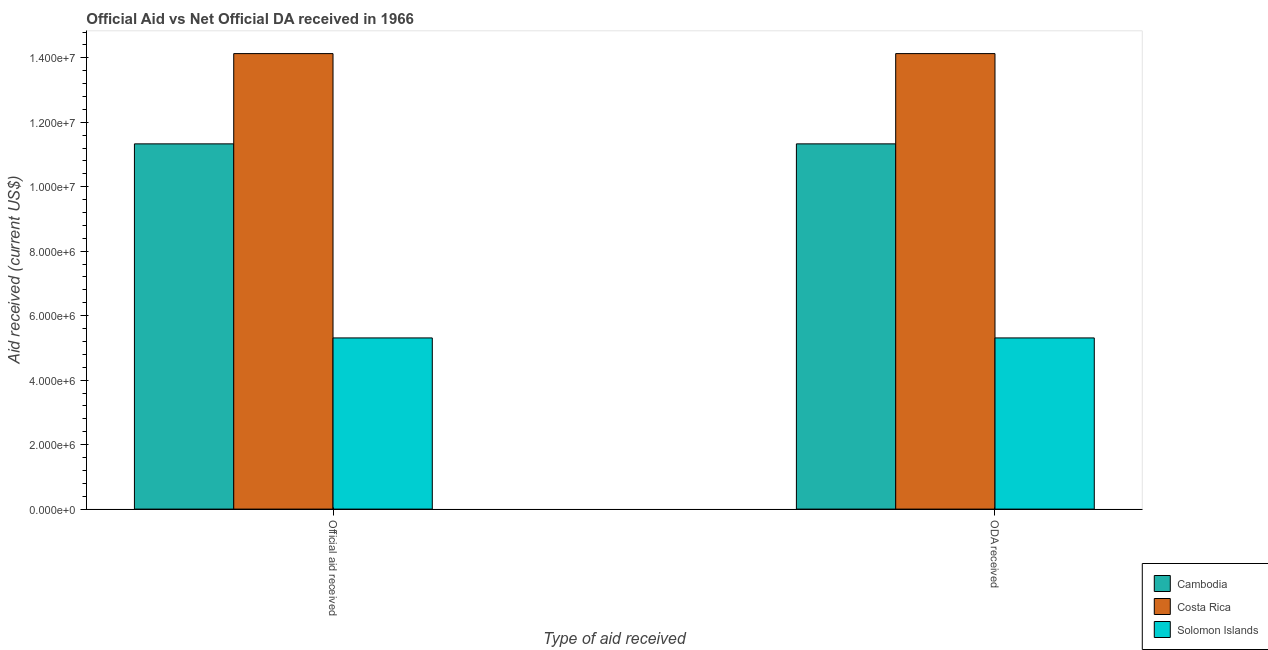Are the number of bars on each tick of the X-axis equal?
Ensure brevity in your answer.  Yes. What is the label of the 1st group of bars from the left?
Keep it short and to the point. Official aid received. What is the oda received in Costa Rica?
Keep it short and to the point. 1.41e+07. Across all countries, what is the maximum official aid received?
Your response must be concise. 1.41e+07. Across all countries, what is the minimum official aid received?
Provide a succinct answer. 5.31e+06. In which country was the oda received minimum?
Your answer should be very brief. Solomon Islands. What is the total official aid received in the graph?
Provide a succinct answer. 3.08e+07. What is the difference between the oda received in Solomon Islands and that in Costa Rica?
Your answer should be compact. -8.82e+06. What is the difference between the oda received in Cambodia and the official aid received in Solomon Islands?
Offer a very short reply. 6.02e+06. What is the average official aid received per country?
Your answer should be very brief. 1.03e+07. What is the difference between the official aid received and oda received in Costa Rica?
Provide a short and direct response. 0. In how many countries, is the oda received greater than 11200000 US$?
Offer a terse response. 2. What is the ratio of the oda received in Costa Rica to that in Solomon Islands?
Offer a terse response. 2.66. What does the 3rd bar from the left in ODA received represents?
Your response must be concise. Solomon Islands. What does the 1st bar from the right in ODA received represents?
Make the answer very short. Solomon Islands. How many bars are there?
Provide a short and direct response. 6. Are the values on the major ticks of Y-axis written in scientific E-notation?
Your response must be concise. Yes. What is the title of the graph?
Provide a succinct answer. Official Aid vs Net Official DA received in 1966 . What is the label or title of the X-axis?
Offer a very short reply. Type of aid received. What is the label or title of the Y-axis?
Your answer should be compact. Aid received (current US$). What is the Aid received (current US$) in Cambodia in Official aid received?
Your response must be concise. 1.13e+07. What is the Aid received (current US$) in Costa Rica in Official aid received?
Provide a short and direct response. 1.41e+07. What is the Aid received (current US$) in Solomon Islands in Official aid received?
Your answer should be very brief. 5.31e+06. What is the Aid received (current US$) of Cambodia in ODA received?
Give a very brief answer. 1.13e+07. What is the Aid received (current US$) in Costa Rica in ODA received?
Give a very brief answer. 1.41e+07. What is the Aid received (current US$) of Solomon Islands in ODA received?
Make the answer very short. 5.31e+06. Across all Type of aid received, what is the maximum Aid received (current US$) in Cambodia?
Offer a very short reply. 1.13e+07. Across all Type of aid received, what is the maximum Aid received (current US$) in Costa Rica?
Give a very brief answer. 1.41e+07. Across all Type of aid received, what is the maximum Aid received (current US$) of Solomon Islands?
Provide a short and direct response. 5.31e+06. Across all Type of aid received, what is the minimum Aid received (current US$) of Cambodia?
Your response must be concise. 1.13e+07. Across all Type of aid received, what is the minimum Aid received (current US$) of Costa Rica?
Your answer should be compact. 1.41e+07. Across all Type of aid received, what is the minimum Aid received (current US$) in Solomon Islands?
Your response must be concise. 5.31e+06. What is the total Aid received (current US$) in Cambodia in the graph?
Give a very brief answer. 2.27e+07. What is the total Aid received (current US$) of Costa Rica in the graph?
Give a very brief answer. 2.83e+07. What is the total Aid received (current US$) of Solomon Islands in the graph?
Give a very brief answer. 1.06e+07. What is the difference between the Aid received (current US$) in Costa Rica in Official aid received and that in ODA received?
Provide a succinct answer. 0. What is the difference between the Aid received (current US$) in Cambodia in Official aid received and the Aid received (current US$) in Costa Rica in ODA received?
Offer a terse response. -2.80e+06. What is the difference between the Aid received (current US$) in Cambodia in Official aid received and the Aid received (current US$) in Solomon Islands in ODA received?
Your response must be concise. 6.02e+06. What is the difference between the Aid received (current US$) in Costa Rica in Official aid received and the Aid received (current US$) in Solomon Islands in ODA received?
Provide a short and direct response. 8.82e+06. What is the average Aid received (current US$) of Cambodia per Type of aid received?
Offer a very short reply. 1.13e+07. What is the average Aid received (current US$) of Costa Rica per Type of aid received?
Give a very brief answer. 1.41e+07. What is the average Aid received (current US$) in Solomon Islands per Type of aid received?
Give a very brief answer. 5.31e+06. What is the difference between the Aid received (current US$) of Cambodia and Aid received (current US$) of Costa Rica in Official aid received?
Your answer should be compact. -2.80e+06. What is the difference between the Aid received (current US$) of Cambodia and Aid received (current US$) of Solomon Islands in Official aid received?
Offer a terse response. 6.02e+06. What is the difference between the Aid received (current US$) in Costa Rica and Aid received (current US$) in Solomon Islands in Official aid received?
Offer a terse response. 8.82e+06. What is the difference between the Aid received (current US$) of Cambodia and Aid received (current US$) of Costa Rica in ODA received?
Your response must be concise. -2.80e+06. What is the difference between the Aid received (current US$) of Cambodia and Aid received (current US$) of Solomon Islands in ODA received?
Provide a succinct answer. 6.02e+06. What is the difference between the Aid received (current US$) in Costa Rica and Aid received (current US$) in Solomon Islands in ODA received?
Keep it short and to the point. 8.82e+06. What is the ratio of the Aid received (current US$) of Cambodia in Official aid received to that in ODA received?
Offer a terse response. 1. What is the ratio of the Aid received (current US$) of Costa Rica in Official aid received to that in ODA received?
Your answer should be compact. 1. What is the difference between the highest and the second highest Aid received (current US$) in Cambodia?
Your answer should be compact. 0. What is the difference between the highest and the second highest Aid received (current US$) of Costa Rica?
Keep it short and to the point. 0. What is the difference between the highest and the second highest Aid received (current US$) in Solomon Islands?
Offer a very short reply. 0. What is the difference between the highest and the lowest Aid received (current US$) in Cambodia?
Ensure brevity in your answer.  0. What is the difference between the highest and the lowest Aid received (current US$) in Costa Rica?
Provide a succinct answer. 0. What is the difference between the highest and the lowest Aid received (current US$) of Solomon Islands?
Offer a terse response. 0. 